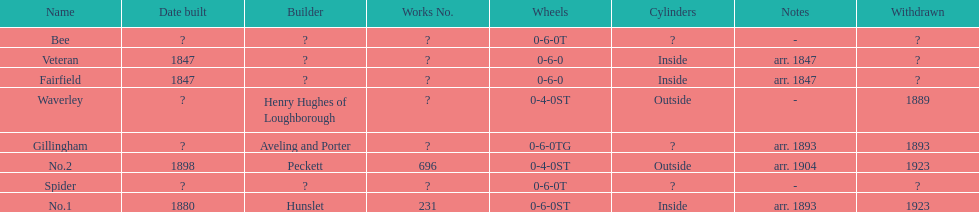What is the total number of names on the chart? 8. 